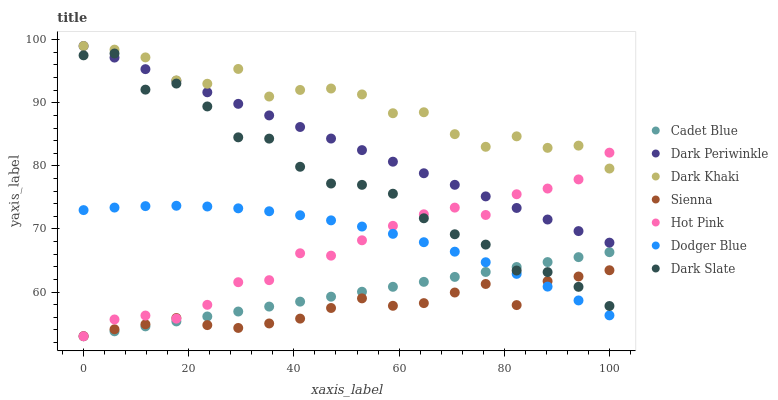Does Sienna have the minimum area under the curve?
Answer yes or no. Yes. Does Dark Khaki have the maximum area under the curve?
Answer yes or no. Yes. Does Cadet Blue have the minimum area under the curve?
Answer yes or no. No. Does Cadet Blue have the maximum area under the curve?
Answer yes or no. No. Is Dark Periwinkle the smoothest?
Answer yes or no. Yes. Is Dark Slate the roughest?
Answer yes or no. Yes. Is Cadet Blue the smoothest?
Answer yes or no. No. Is Cadet Blue the roughest?
Answer yes or no. No. Does Cadet Blue have the lowest value?
Answer yes or no. Yes. Does Dark Khaki have the lowest value?
Answer yes or no. No. Does Dark Periwinkle have the highest value?
Answer yes or no. Yes. Does Cadet Blue have the highest value?
Answer yes or no. No. Is Cadet Blue less than Dark Khaki?
Answer yes or no. Yes. Is Dark Slate greater than Dodger Blue?
Answer yes or no. Yes. Does Dodger Blue intersect Hot Pink?
Answer yes or no. Yes. Is Dodger Blue less than Hot Pink?
Answer yes or no. No. Is Dodger Blue greater than Hot Pink?
Answer yes or no. No. Does Cadet Blue intersect Dark Khaki?
Answer yes or no. No. 